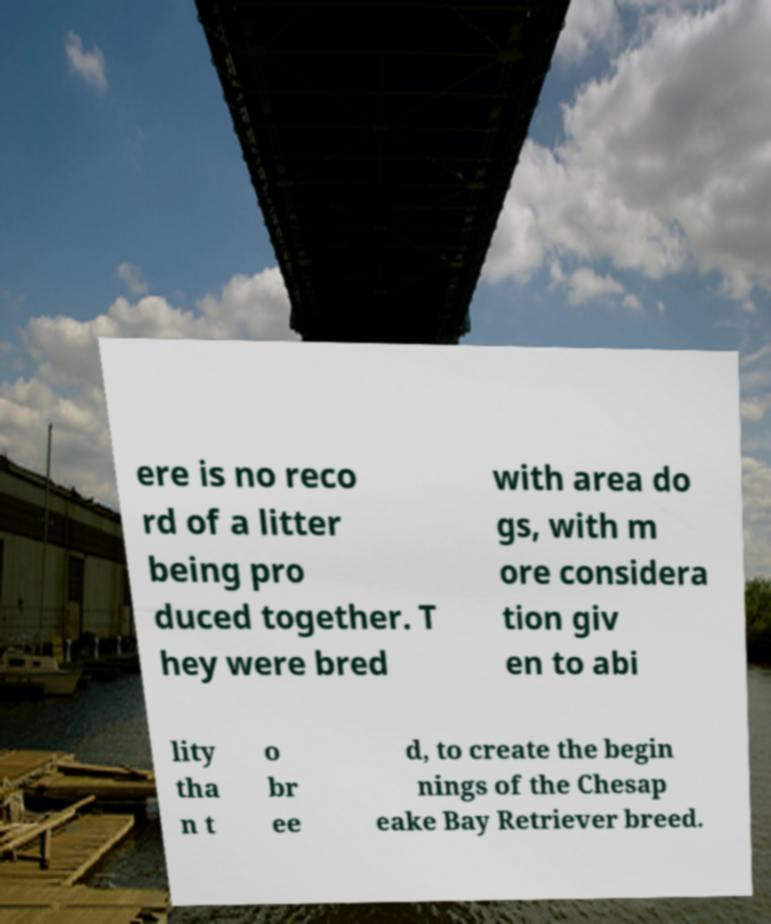Please identify and transcribe the text found in this image. ere is no reco rd of a litter being pro duced together. T hey were bred with area do gs, with m ore considera tion giv en to abi lity tha n t o br ee d, to create the begin nings of the Chesap eake Bay Retriever breed. 